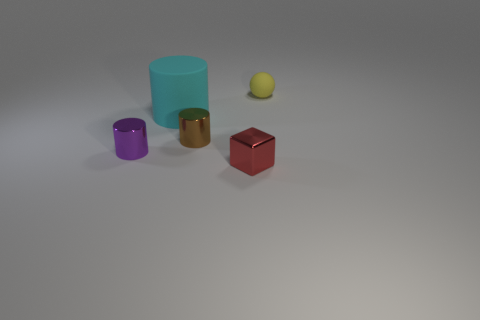What kind of arrangement or pattern do the objects in the image form? The objects in the image are arranged in a loose semi-circle or arc, with varying distances between them. Starting from the left, we see a purple cylinder, a larger cyan-colored cylinder, a small gold-colored cylinder, a sphere that seems a bit further back, and a red block. There is no strict geometric pattern, but their arrangement creates a visually pleasing composition with a balance of color and form. 